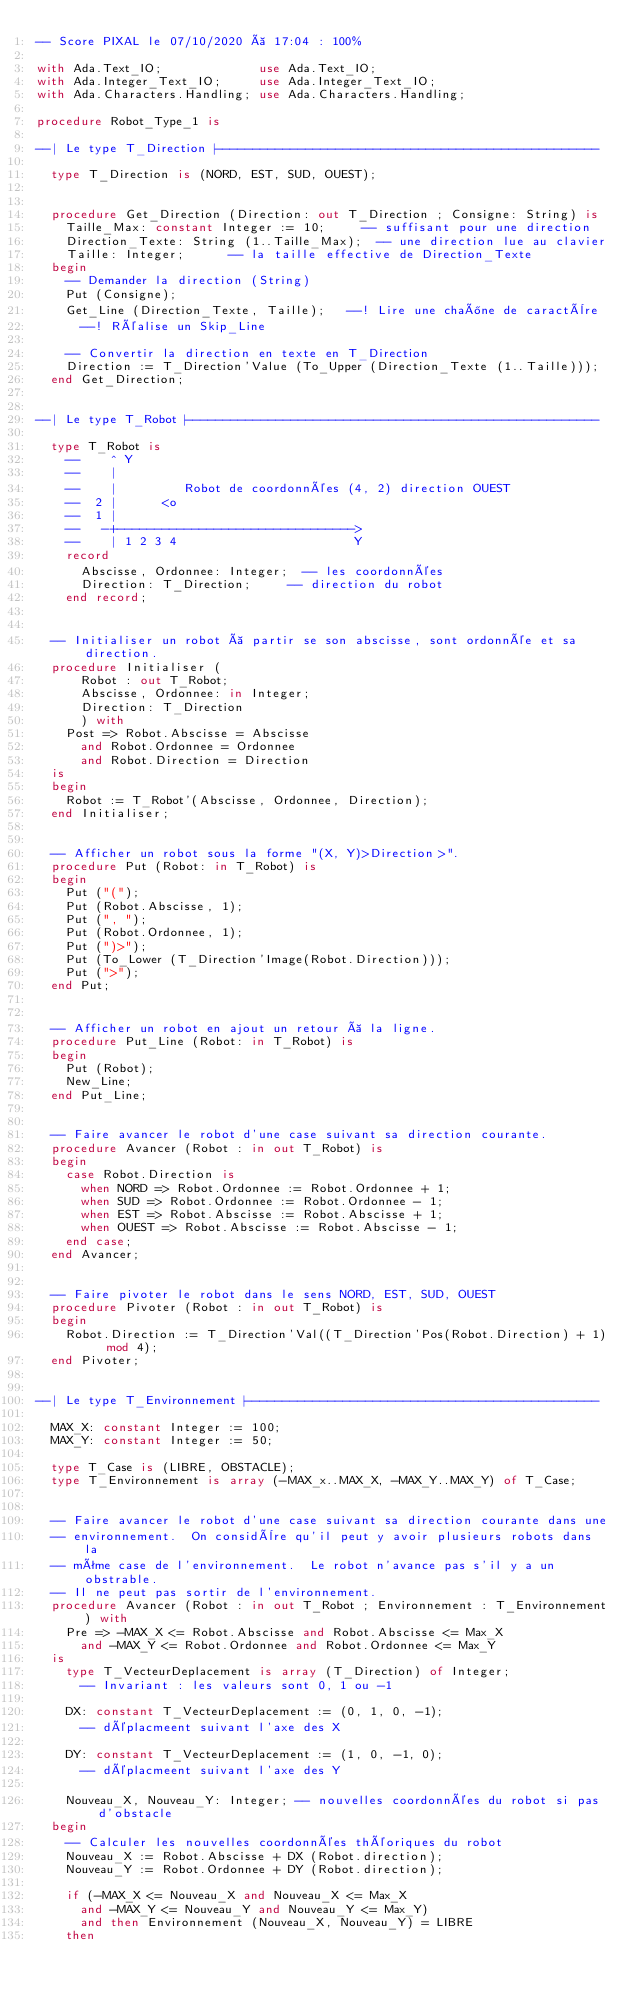<code> <loc_0><loc_0><loc_500><loc_500><_Ada_>-- Score PIXAL le 07/10/2020 à 17:04 : 100%

with Ada.Text_IO;             use Ada.Text_IO;
with Ada.Integer_Text_IO;     use Ada.Integer_Text_IO;
with Ada.Characters.Handling; use Ada.Characters.Handling;

procedure Robot_Type_1 is

--| Le type T_Direction |---------------------------------------------------

	type T_Direction is (NORD, EST, SUD, OUEST);


	procedure Get_Direction (Direction: out T_Direction ; Consigne: String) is
		Taille_Max: constant Integer := 10;			-- suffisant pour une direction
		Direction_Texte: String (1..Taille_Max);	-- une direction lue au clavier
		Taille: Integer;			-- la taille effective de Direction_Texte
	begin
		-- Demander la direction (String)
		Put (Consigne);
		Get_Line (Direction_Texte, Taille);		--! Lire une chaîne de caractère
			--! Réalise un Skip_Line

		-- Convertir la direction en texte en T_Direction
		Direction := T_Direction'Value (To_Upper (Direction_Texte (1..Taille)));
	end Get_Direction;


--| Le type T_Robot |-------------------------------------------------------

	type T_Robot is
		--    ^ Y
		--    |
		--    |         Robot de coordonnées (4, 2) direction OUEST
		--  2 |      <o
		--  1 |
		--   -+-------------------------------->
		--    | 1 2 3 4                        Y
		record
			Abscisse, Ordonnee: Integer;	-- les coordonnées
			Direction: T_Direction;			-- direction du robot
		end record;


	-- Initialiser un robot à partir se son abscisse, sont ordonnée et sa direction.
	procedure Initialiser (
			Robot : out T_Robot;
			Abscisse, Ordonnee: in Integer;
			Direction: T_Direction
			) with
		Post => Robot.Abscisse = Abscisse
			and Robot.Ordonnee = Ordonnee
			and Robot.Direction = Direction
	is
	begin
		Robot := T_Robot'(Abscisse, Ordonnee, Direction);
	end Initialiser;


	-- Afficher un robot sous la forme "(X, Y)>Direction>".
	procedure Put (Robot: in T_Robot) is
	begin
		Put ("(");
		Put (Robot.Abscisse, 1);
		Put (", ");
		Put (Robot.Ordonnee, 1);
		Put (")>");
		Put (To_Lower (T_Direction'Image(Robot.Direction)));
		Put (">");
	end Put;


	-- Afficher un robot en ajout un retour à la ligne.
	procedure Put_Line (Robot: in T_Robot) is
	begin
		Put (Robot);
		New_Line;
	end Put_Line;


	-- Faire avancer le robot d'une case suivant sa direction courante.
	procedure Avancer (Robot : in out T_Robot) is
	begin
		case Robot.Direction is
			when NORD => Robot.Ordonnee := Robot.Ordonnee + 1;
			when SUD => Robot.Ordonnee := Robot.Ordonnee - 1;
			when EST => Robot.Abscisse := Robot.Abscisse + 1;
			when OUEST => Robot.Abscisse := Robot.Abscisse - 1;
		end case;
	end Avancer;


	-- Faire pivoter le robot dans le sens NORD, EST, SUD, OUEST
	procedure Pivoter (Robot : in out T_Robot) is
	begin
		Robot.Direction := T_Direction'Val((T_Direction'Pos(Robot.Direction) + 1) mod 4);
	end Pivoter;


--| Le type T_Environnement |-----------------------------------------------

	MAX_X: constant Integer := 100;
	MAX_Y: constant Integer := 50;

	type T_Case is (LIBRE, OBSTACLE);
	type T_Environnement is array (-MAX_x..MAX_X, -MAX_Y..MAX_Y) of T_Case;


	-- Faire avancer le robot d'une case suivant sa direction courante dans une
	-- environnement.  On considère qu'il peut y avoir plusieurs robots dans la
	-- même case de l'environnement.  Le robot n'avance pas s'il y a un obstrable.
	-- Il ne peut pas sortir de l'environnement.
	procedure Avancer (Robot : in out T_Robot ; Environnement : T_Environnement) with
		Pre => -MAX_X <= Robot.Abscisse and Robot.Abscisse <= Max_X
			and -MAX_Y <= Robot.Ordonnee and Robot.Ordonnee <= Max_Y
	is
		type T_VecteurDeplacement is array (T_Direction) of Integer;
			-- Invariant : les valeurs sont 0, 1 ou -1

		DX: constant T_VecteurDeplacement := (0, 1, 0, -1);
			-- déplacmeent suivant l'axe des X

		DY: constant T_VecteurDeplacement := (1, 0, -1, 0);
			-- déplacmeent suivant l'axe des Y

		Nouveau_X, Nouveau_Y: Integer; -- nouvelles coordonnées du robot si pas d'obstacle
	begin
		-- Calculer les nouvelles coordonnées théoriques du robot
		Nouveau_X := Robot.Abscisse + DX (Robot.direction);
		Nouveau_Y := Robot.Ordonnee + DY (Robot.direction);

		if (-MAX_X <= Nouveau_X and Nouveau_X <= Max_X
			and -MAX_Y <= Nouveau_Y and Nouveau_Y <= Max_Y)
			and then Environnement (Nouveau_X, Nouveau_Y) = LIBRE
		then</code> 